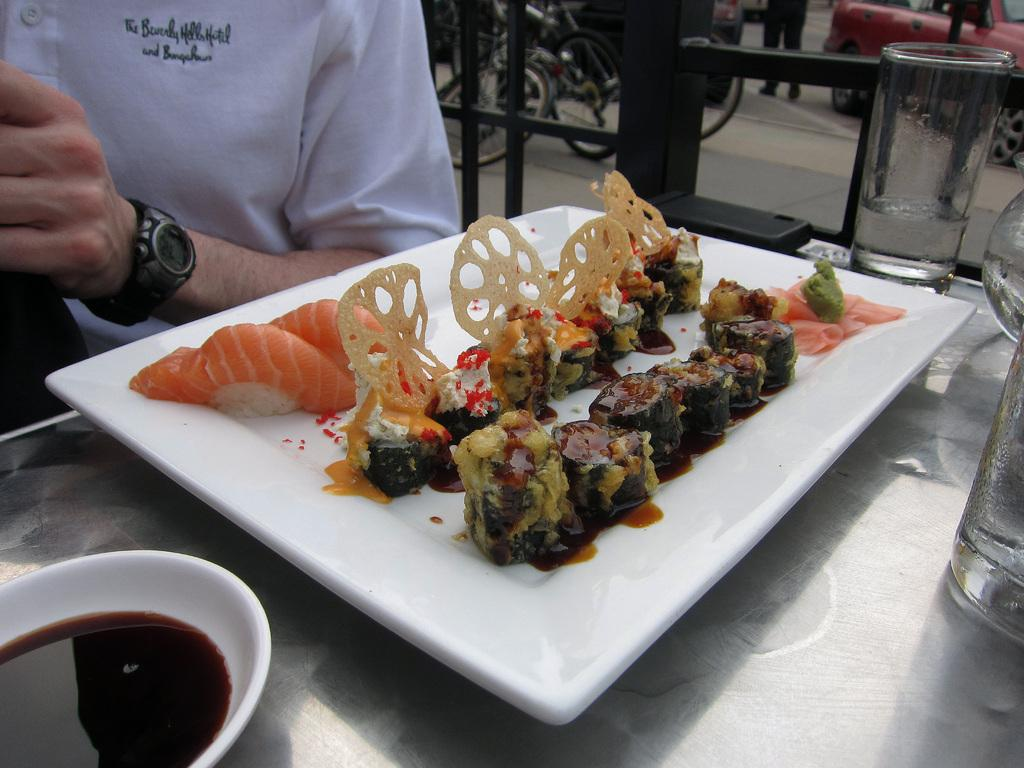What is on the plate in the image? There is a plate with food items in the image. Can you describe anything else visible in the image? A person's hand is visible on the top left side of the image, and there is a glass on the top right side of the image. What type of apparel is the person wearing in the image? There is no person visible in the image, only a hand. Can you describe the car that is parked next to the plate in the image? There is no car present in the image. 